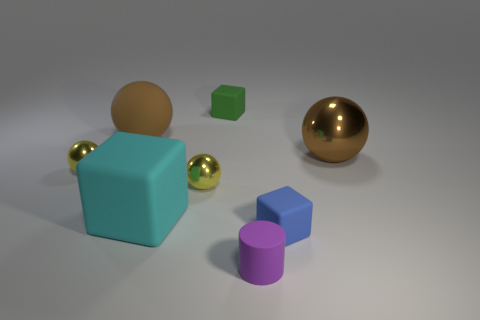Add 1 blue blocks. How many objects exist? 9 Subtract all green cubes. Subtract all cyan cylinders. How many cubes are left? 2 Subtract all cylinders. How many objects are left? 7 Add 2 matte cylinders. How many matte cylinders are left? 3 Add 6 tiny green blocks. How many tiny green blocks exist? 7 Subtract 0 cyan cylinders. How many objects are left? 8 Subtract all brown rubber things. Subtract all cyan cubes. How many objects are left? 6 